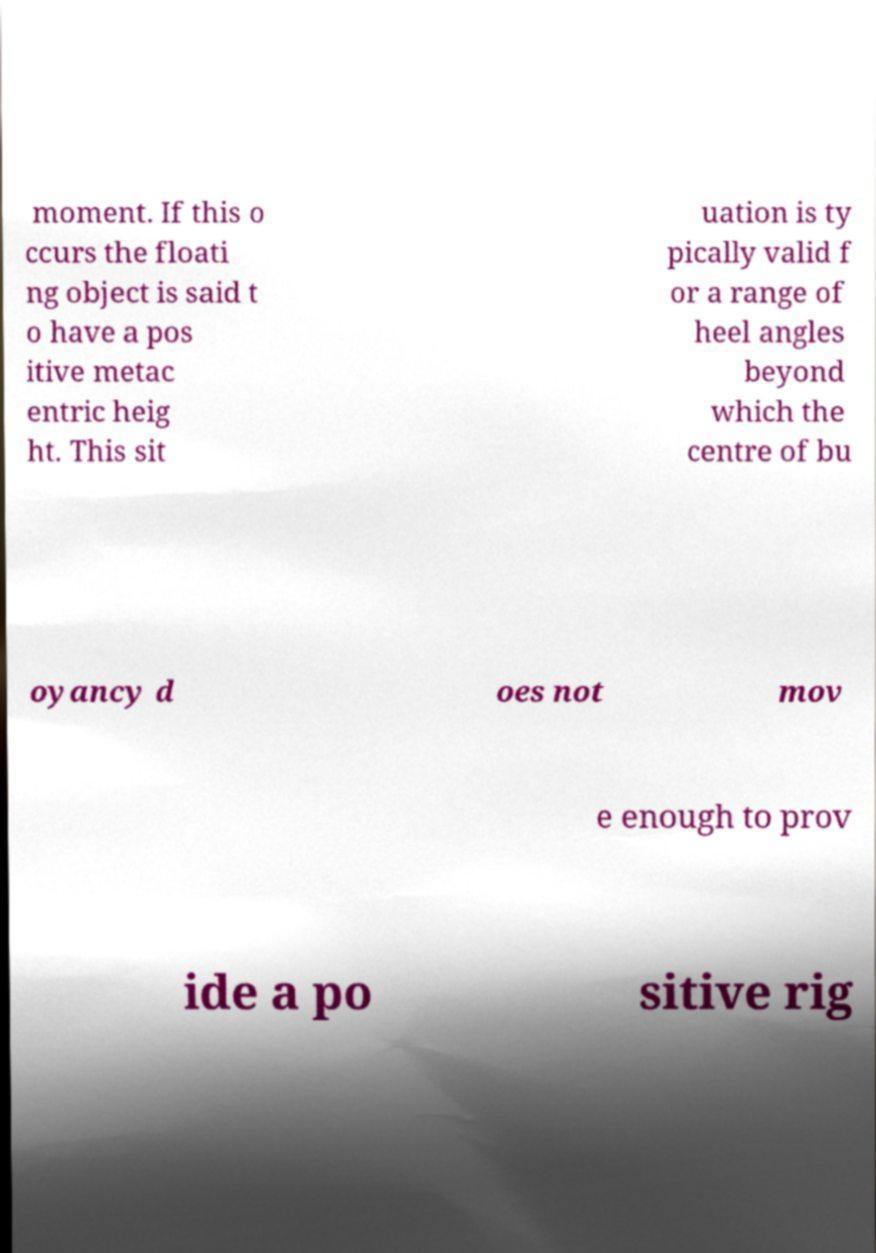There's text embedded in this image that I need extracted. Can you transcribe it verbatim? moment. If this o ccurs the floati ng object is said t o have a pos itive metac entric heig ht. This sit uation is ty pically valid f or a range of heel angles beyond which the centre of bu oyancy d oes not mov e enough to prov ide a po sitive rig 